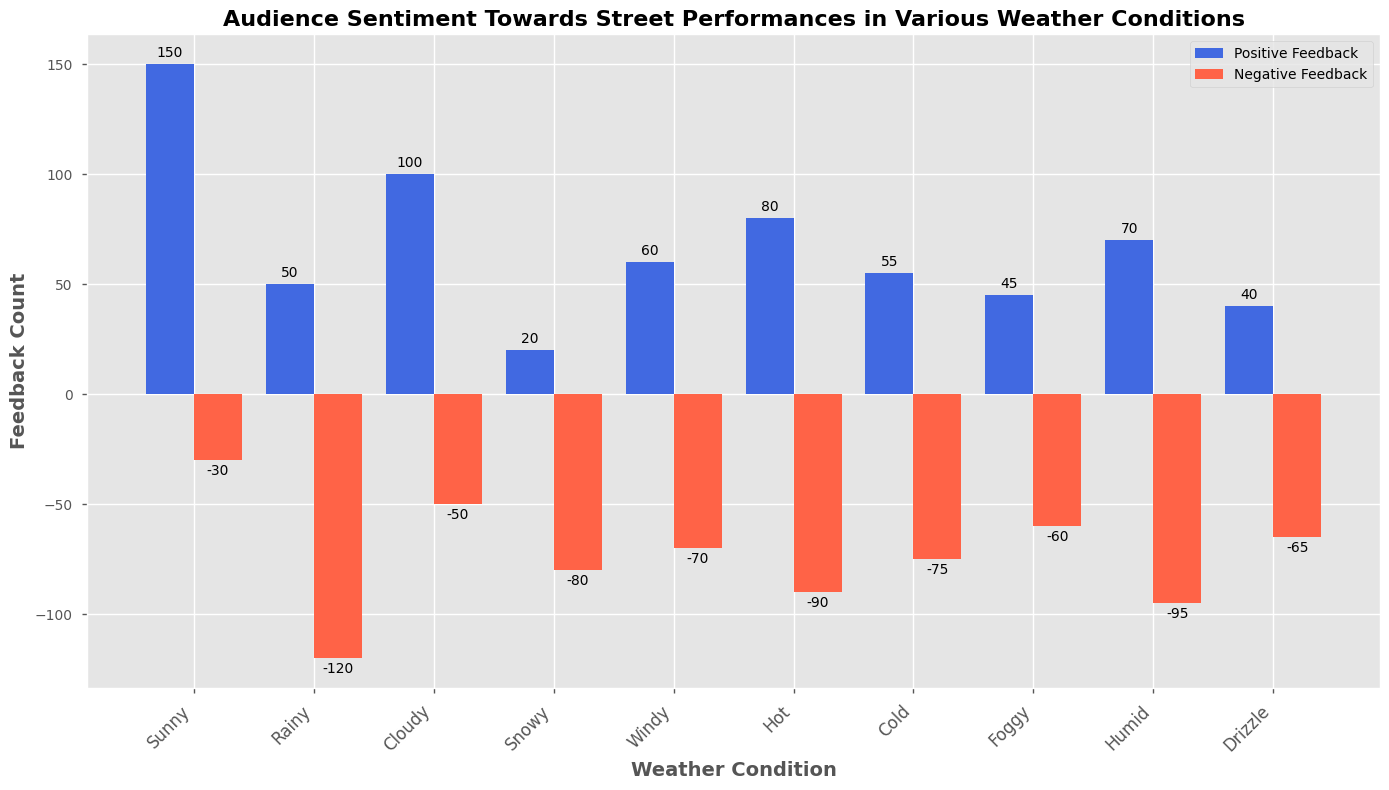What weather condition has the highest positive feedback? The bar for 'Sunny' is the tallest among the positive feedback bars, indicating it has the highest positive feedback.
Answer: Sunny Which weather condition has the most negative feedback? The bar for 'Rainy' in negative feedback is the lowest (most negative value), indicating it has the most negative feedback.
Answer: Rainy How much more positive feedback does 'Sunny' have compared to 'Rainy'? The positive feedback for 'Sunny' is 150 and for 'Rainy' is 50. The difference is 150 - 50 = 100.
Answer: 100 Which weather condition has nearly equal positive and negative feedback? 'Cloudy' has 100 positive feedback and -50 negative feedback, which are the closest values in magnitude across all conditions.
Answer: Cloudy What is the combined (absolute) negative feedback for 'Hot' and 'Cold'? The negative feedback for 'Hot' is -90 and for 'Cold' is -75. The combined feedback is 90 + 75 = 165.
Answer: 165 What are the weather conditions with negative feedback less than -60? Negative feedback bars lower than -60 are found for 'Rainy', 'Hot', 'Snowy', and 'Cold'.
Answer: Rainy, Hot, Snowy, Cold Which weather condition has more negative feedback than positive feedback? 'Rainy', 'Snowy', 'Windy', 'Hot', 'Cold', 'Foggy', 'Humid', and 'Drizzle' all have negative feedback bars lower (more negative) than their respective positive feedback bars.
Answer: Rainy, Snowy, Windy, Hot, Cold, Foggy, Humid, Drizzle How much is the total positive feedback for 'Sunny' and 'Cloudy' combined? The positive feedback for 'Sunny' is 150 and for 'Cloudy' is 100. Added together, the total is 150 + 100 = 250.
Answer: 250 Which weather condition has a positive feedback between 40 and 60? The positive feedback for 'Foggy' is 45, which is between 40 and 60.
Answer: Foggy 